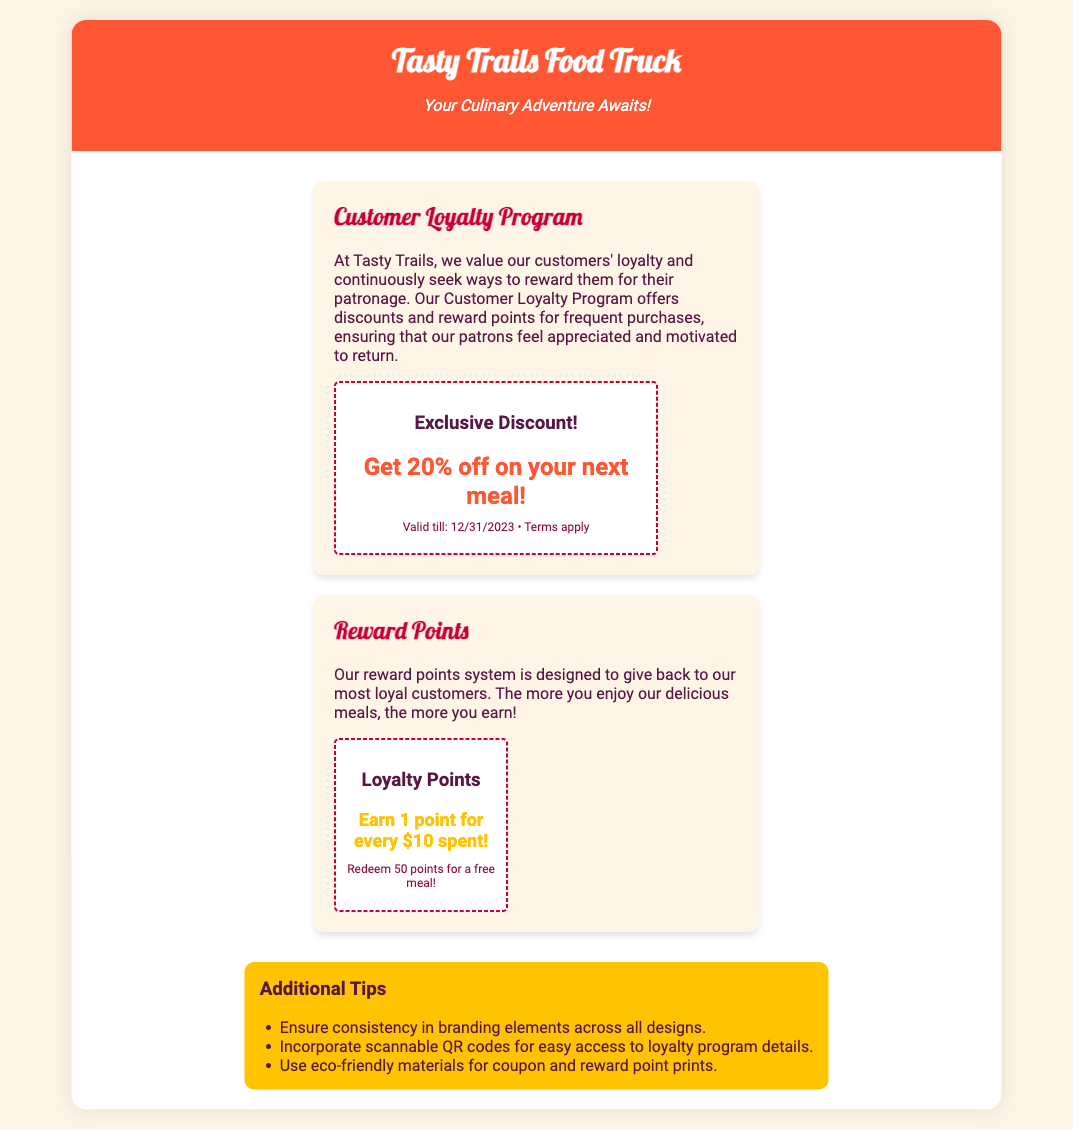What is the name of the food truck? The name of the food truck is mentioned at the top of the document, which is Tasty Trails Food Truck.
Answer: Tasty Trails Food Truck What is the discount percentage offered? The document states that customers can get a discount of 20% on their next meal.
Answer: 20% How many points do you earn for every ten dollars spent? According to the reward points section, customers earn 1 point for every $10 spent.
Answer: 1 point What is the validity date for the exclusive discount coupon? The validity date for the exclusive discount coupon is mentioned as 12/31/2023.
Answer: 12/31/2023 How many loyalty points are needed for a free meal? The document specifies that redeeming 50 points will get you a free meal.
Answer: 50 points What should be ensured in branding elements across designs? The document advises ensuring consistency in branding elements across all designs.
Answer: Consistency What type of materials should be used for coupon prints? It is recommended to use eco-friendly materials for coupon and reward point prints.
Answer: Eco-friendly materials What motivates patrons to return? The loyalty program is designed to ensure that patrons feel appreciated and motivated to return.
Answer: Appreciation What is included in the additional tips section? The additional tips section includes suggestions for branding consistency, QR codes, and eco-friendly materials.
Answer: Branding consistency, QR codes, eco-friendly materials 